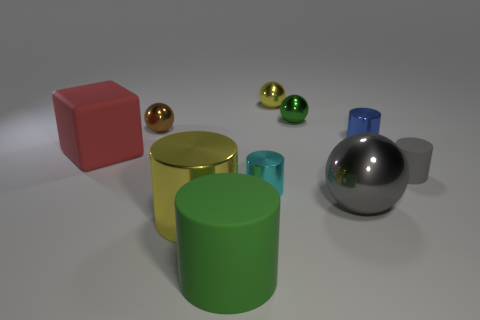What could be the function of the various shaped objects in the scene? The objects in the scene, with their distinct shapes and materials, could be part of a visual study or demonstration. Each shape, whether cylinder, sphere, or block, might be used to illustrate geometric principles, reflectivity, and shadow casting in a 3D modeling or graphic design setting. Their placement and varied materials suggest a setup to explore and teach about different visual and physical properties. 